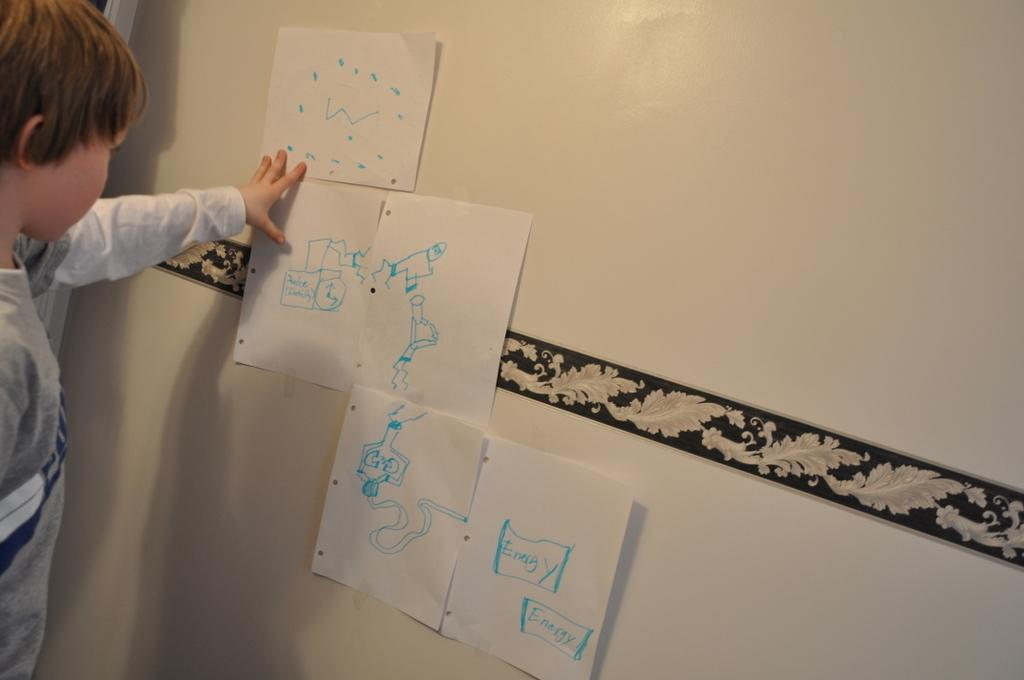<image>
Share a concise interpretation of the image provided. A child looks at pieces of paper with a diagram that says energy at the end of the chart. 